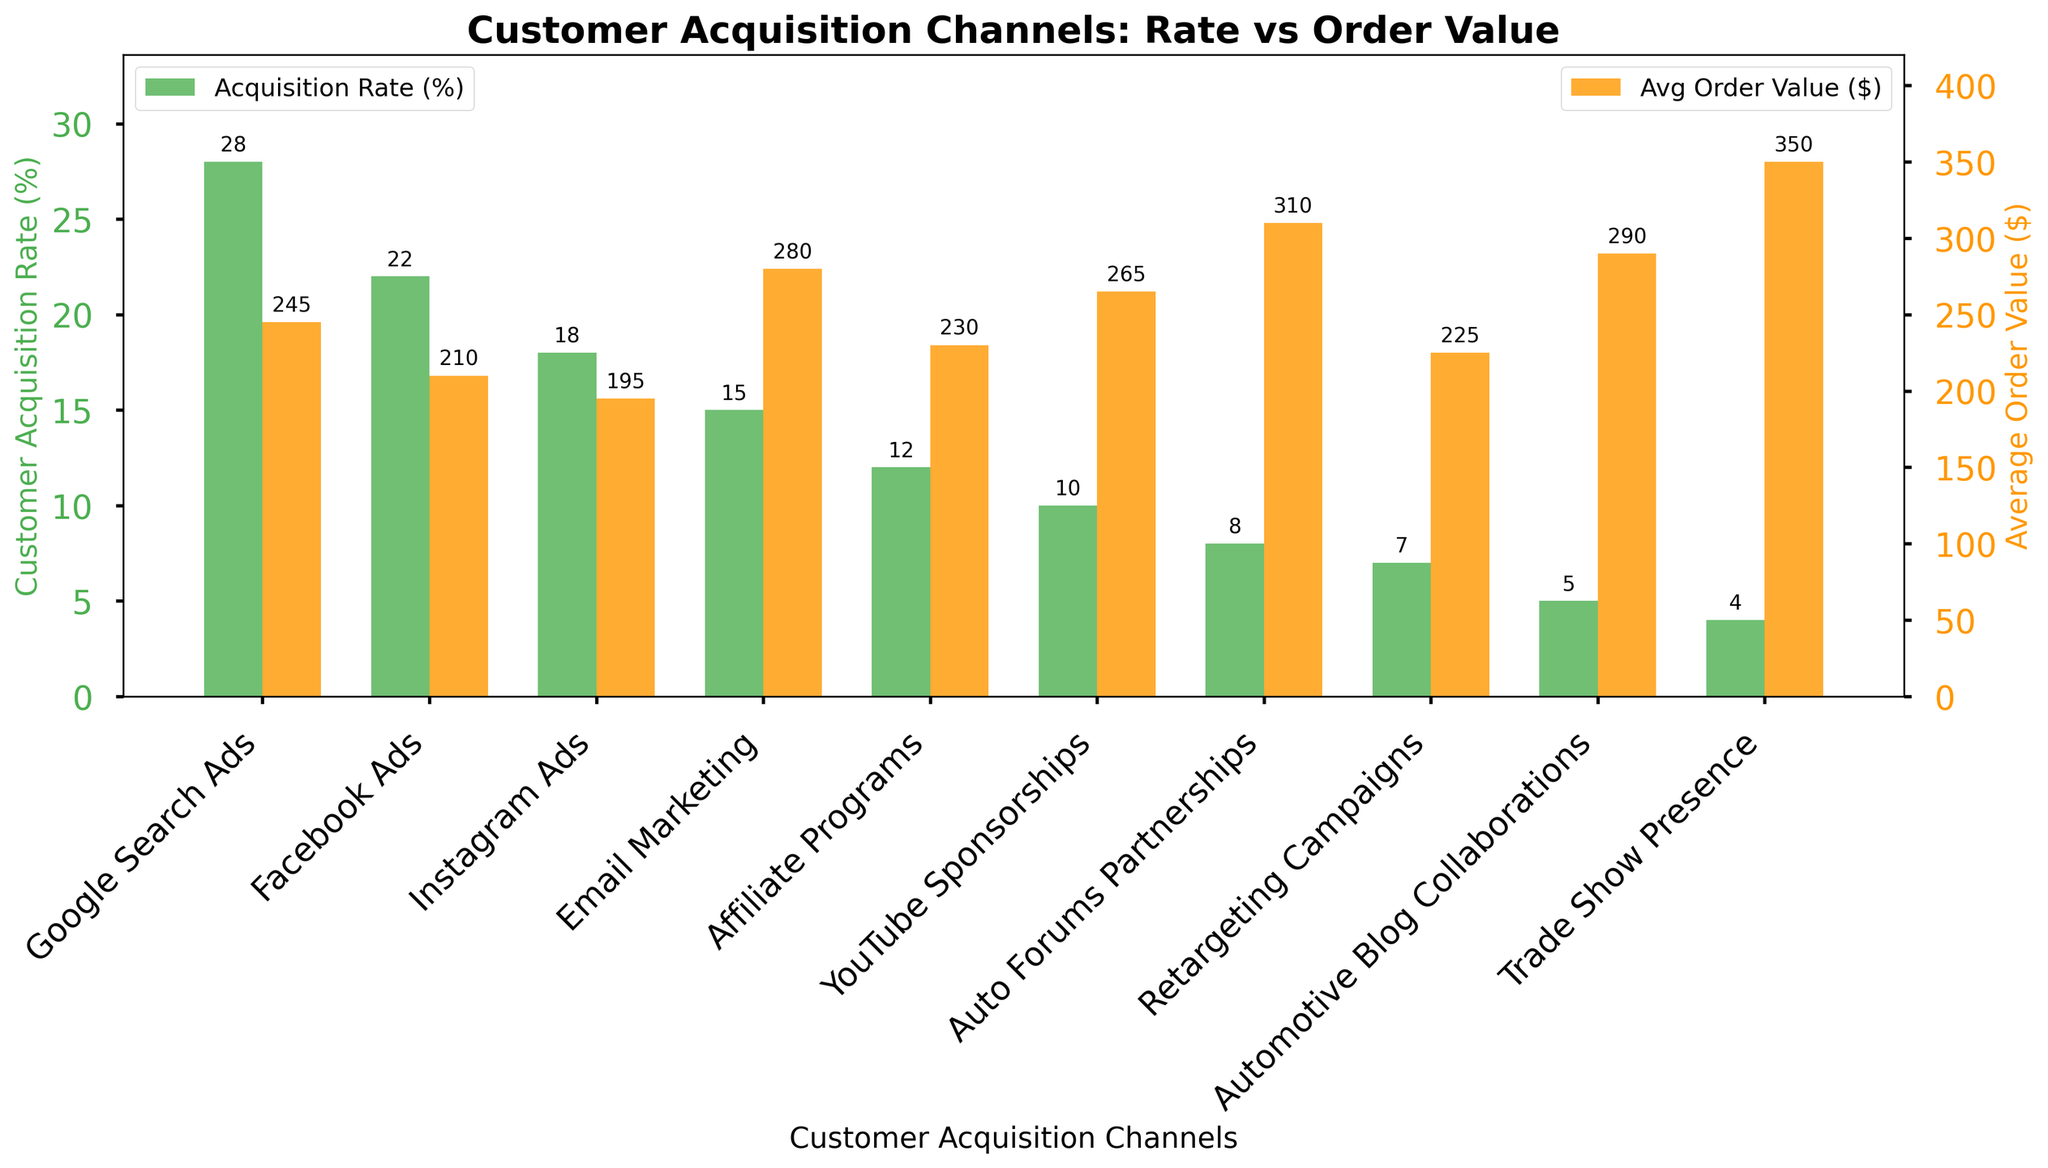What is the customer acquisition rate for Trade Show Presence? Look at the green bar associated with Trade Show Presence; its height indicates the customer acquisition rate, which is 4%.
Answer: 4% Which customer acquisition channel has the highest average order value? Identify the highest orange bar and check the associated channel, which corresponds to Trade Show Presence with an average order value of $350.
Answer: Trade Show Presence What is the difference in customer acquisition rate between Google Search Ads and YouTube Sponsorships? Find the heights of the green bars for Google Search Ads and YouTube Sponsorships, which are 28% and 10% respectively. Calculate the difference: 28% - 10% = 18%.
Answer: 18% Which channel has a higher customer acquisition rate: Email Marketing or Instagram Ads? Compare the heights of the green bars for Email Marketing and Instagram Ads; Email Marketing has a lower rate of 15% compared to Instagram Ads' 18%.
Answer: Instagram Ads What is the combined average order value of Auto Forums Partnerships and Automotive Blog Collaborations? Add the heights of the orange bars for Auto Forums Partnerships ($310) and Automotive Blog Collaborations ($290): 310 + 290 = 600.
Answer: 600 How many more customer acquisitions does Google Search Ads have compared to Affiliate Programs, percentage-wise? Find the heights of the green bars for Google Search Ads and Affiliate Programs, which are 28% and 12% respectively. The difference is 28% - 12% = 16%.
Answer: 16% Compare the average order value of Email Marketing with Google Search Ads. Which one is higher? Look at the heights of the orange bars for Email Marketing and Google Search Ads: Email Marketing has a higher average order value of $280 compared to Google Search Ads' $245.
Answer: Email Marketing Which has a lower average order value: Retargeting Campaigns or YouTube Sponsorships? Compare the heights of the orange bars for Retargeting Campaigns ($225) and YouTube Sponsorships ($265). The lower average order value is for Retargeting Campaigns.
Answer: Retargeting Campaigns What is the sum of customer acquisition rates for Facebook Ads, Instagram Ads, and Affiliate Programs? Add the heights of the green bars for Facebook Ads (22%), Instagram Ads (18%), and Affiliate Programs (12%): 22 + 18 + 12 = 52.
Answer: 52 Which has a greater difference: the customer acquisition rates between Email Marketing and Retargeting Campaigns or the average order values between Auto Forums Partnerships and Instagram Ads? Calculate the differences: Email Marketing (15%) - Retargeting Campaigns (7%) = 8%; Auto Forums Partnerships ($310) - Instagram Ads ($195) = $115. The latter difference is greater.
Answer: Average order values between Auto Forums Partnerships and Instagram Ads 